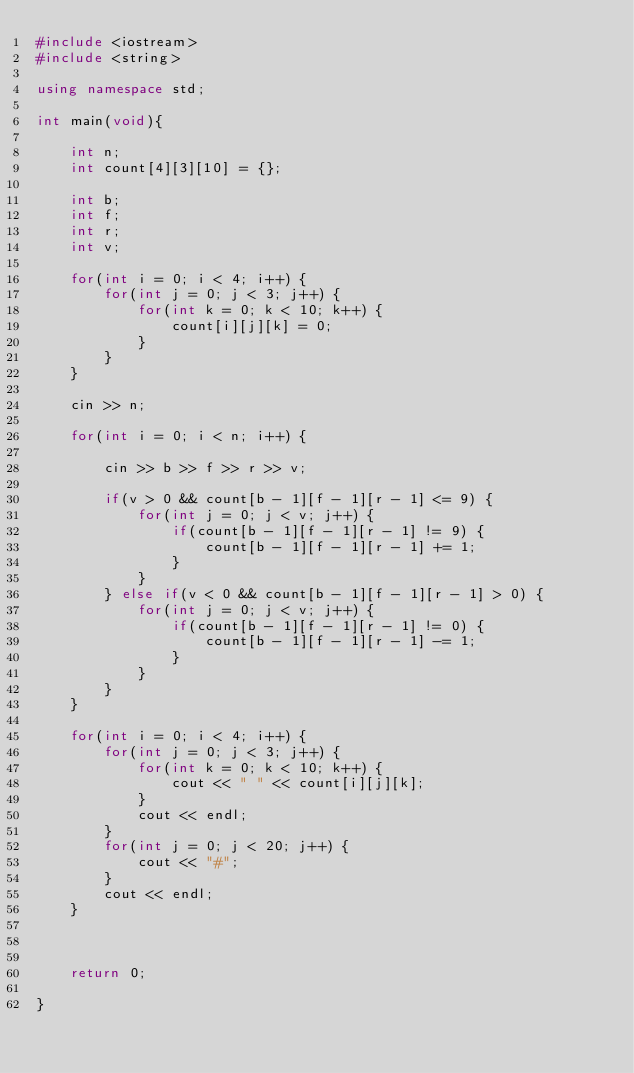<code> <loc_0><loc_0><loc_500><loc_500><_C++_>#include <iostream>
#include <string>

using namespace std;

int main(void){
    
    int n;
    int count[4][3][10] = {};
    
    int b;
    int f;
    int r;
    int v;
    
    for(int i = 0; i < 4; i++) {
        for(int j = 0; j < 3; j++) {
            for(int k = 0; k < 10; k++) {
                count[i][j][k] = 0;
            }
        }
    }
    
    cin >> n;
    
    for(int i = 0; i < n; i++) {
        
        cin >> b >> f >> r >> v;
        
        if(v > 0 && count[b - 1][f - 1][r - 1] <= 9) {
            for(int j = 0; j < v; j++) {
                if(count[b - 1][f - 1][r - 1] != 9) {
                    count[b - 1][f - 1][r - 1] += 1;
                }
            }
        } else if(v < 0 && count[b - 1][f - 1][r - 1] > 0) {
            for(int j = 0; j < v; j++) {
                if(count[b - 1][f - 1][r - 1] != 0) {
                    count[b - 1][f - 1][r - 1] -= 1;
                }
            }
        }
    }
    
    for(int i = 0; i < 4; i++) {
        for(int j = 0; j < 3; j++) {
            for(int k = 0; k < 10; k++) {
                cout << " " << count[i][j][k];
            }
            cout << endl;
        }
        for(int j = 0; j < 20; j++) {
            cout << "#";
        }
        cout << endl;
    }
    
    
    
    return 0;
    
}</code> 